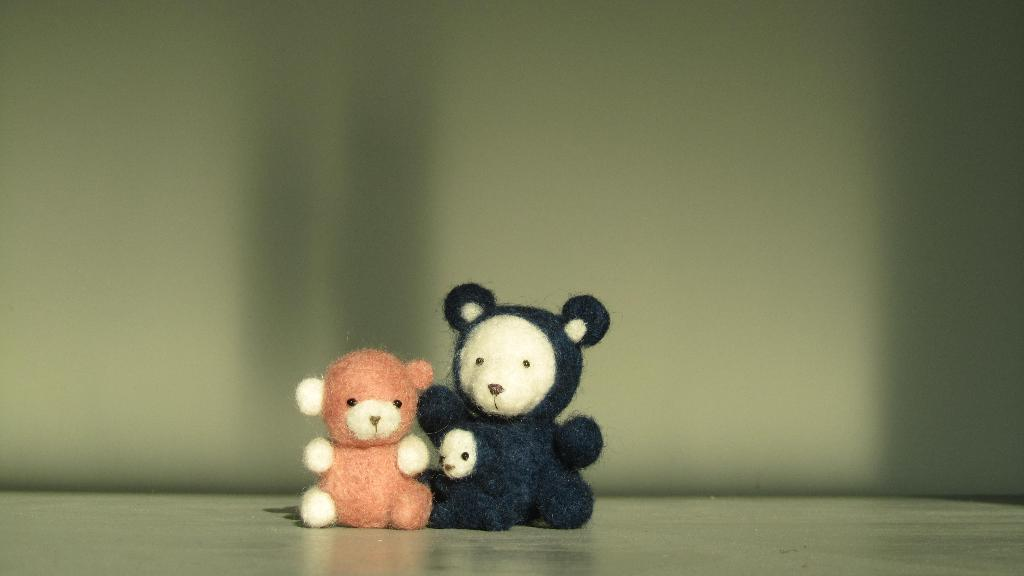How many teddy bears are present in the image? There are two teddy bears in the image. Where are the teddy bears located? The teddy bears are on the floor. What type of discovery did the hen make in the image? There is no hen present in the image, so no discovery can be made by a hen. 